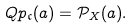Convert formula to latex. <formula><loc_0><loc_0><loc_500><loc_500>Q p _ { \mathfrak c } ( a ) = \mathcal { P } _ { X } ( a ) .</formula> 